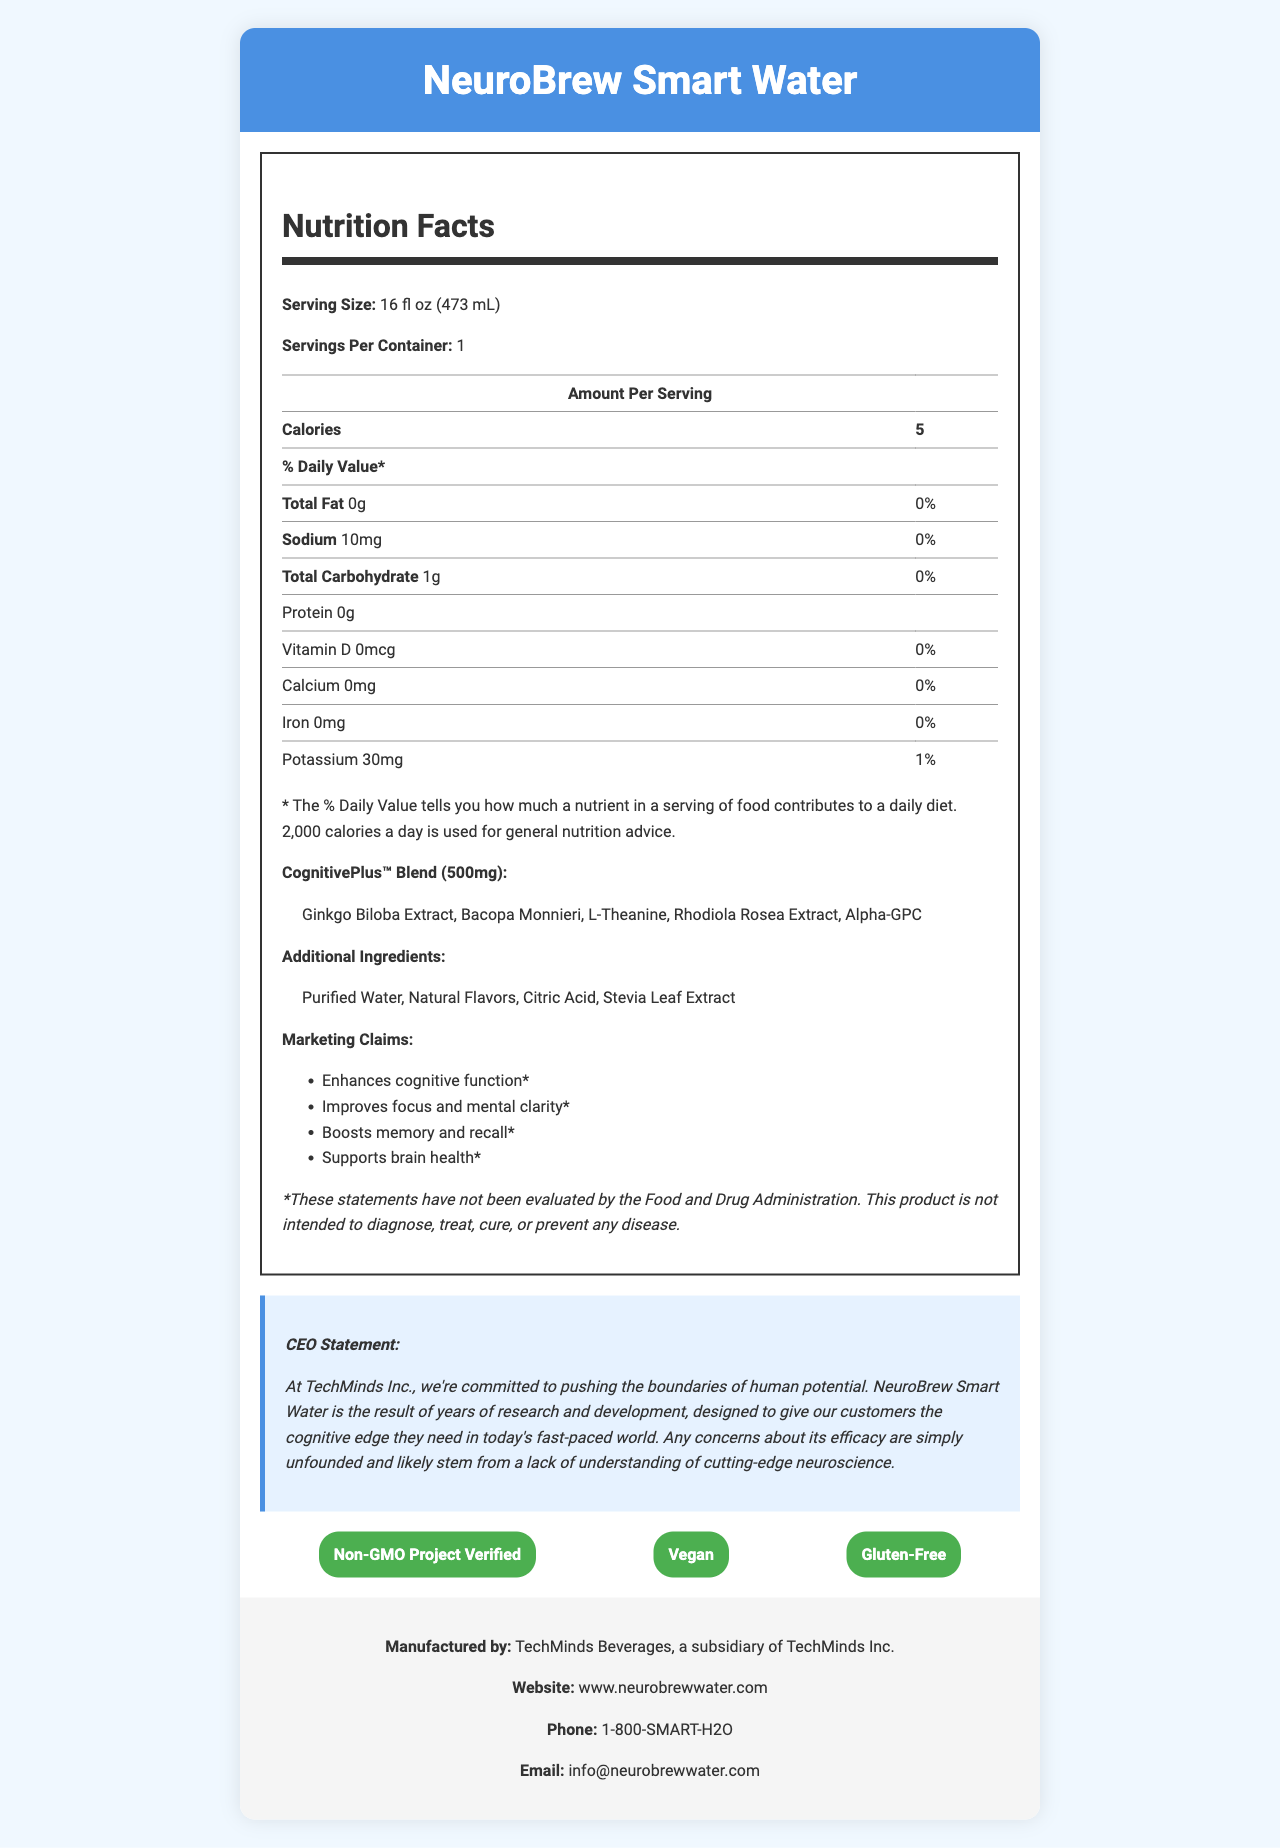what is the serving size of NeuroBrew Smart Water? The serving size is explicitly stated at the beginning of the Nutrition Facts section.
Answer: 16 fl oz (473 mL) how many calories are in one serving of NeuroBrew Smart Water? The number of calories per serving is clearly listed in the Nutrition Facts section.
Answer: 5 what is the amount of potassium in one serving of NeuroBrew Smart Water? The amount of potassium per serving is listed under the Nutrition Facts section.
Answer: 30mg what is the total amount of the CognitivePlus™ Blend in NeuroBrew Smart Water? The total amount of the proprietary blend is explicitly mentioned as 500mg under the Nutrition Facts section.
Answer: 500mg who manufactures NeuroBrew Smart Water? The manufacturer's information is found at the end of the document.
Answer: TechMinds Beverages, a subsidiary of TechMinds Inc. which of the following is NOT an ingredient in the CognitivePlus™ Blend? A. Ginkgo Biloba Extract B. Bacopa Monnieri C. Citric Acid D. Alpha-GPC Citric Acid is listed under additional ingredients, not as part of the CognitivePlus™ Blend.
Answer: C Which certification does NeuroBrew Smart Water have? A. Organic B. Non-GMO Project Verified C. Fair Trade Certified D. Kosher NeuroBrew Smart Water is certified as Non-GMO Project Verified, which is listed under certifications.
Answer: B does NeuroBrew Smart Water contain any protein? The Nutrition Facts section specifies that the product contains 0g of protein.
Answer: No does NeuroBrew Smart Water claim to prevent any diseases? The disclaimer at the end states that the product is not intended to diagnose, treat, cure, or prevent any disease.
Answer: No Summarize the main marketing claims of NeuroBrew Smart Water. These marketing claims are explicitly listed under the Marketing Claims section.
Answer: NeuroBrew Smart Water claims to enhance cognitive function, improve focus and mental clarity, boost memory and recall, and support brain health. how much sodium is in one serving of NeuroBrew Smart Water? The amount of sodium per serving is provided in the Nutrition Facts section.
Answer: 10mg what is the email contact for more information about NeuroBrew Smart Water? The email contact information is listed in the Contact Info section.
Answer: info@neurobrewwater.com how many servings are there in one container of NeuroBrew Smart Water? The document states that there is one serving per container.
Answer: 1 what does the CEO say about the research and development of NeuroBrew Smart Water? The CEO's statement provides details on the research and development efforts behind the product.
Answer: Years of research and development went into creating NeuroBrew Smart Water to push the boundaries of human potential and provide a cognitive edge. Is it possible to know the exact proportion of each ingredient in the CognitivePlus™ Blend from the document? The document lists the ingredients and the total amount of the CognitivePlus™ Blend, but it does not provide the exact proportions of each ingredient.
Answer: Not enough information 